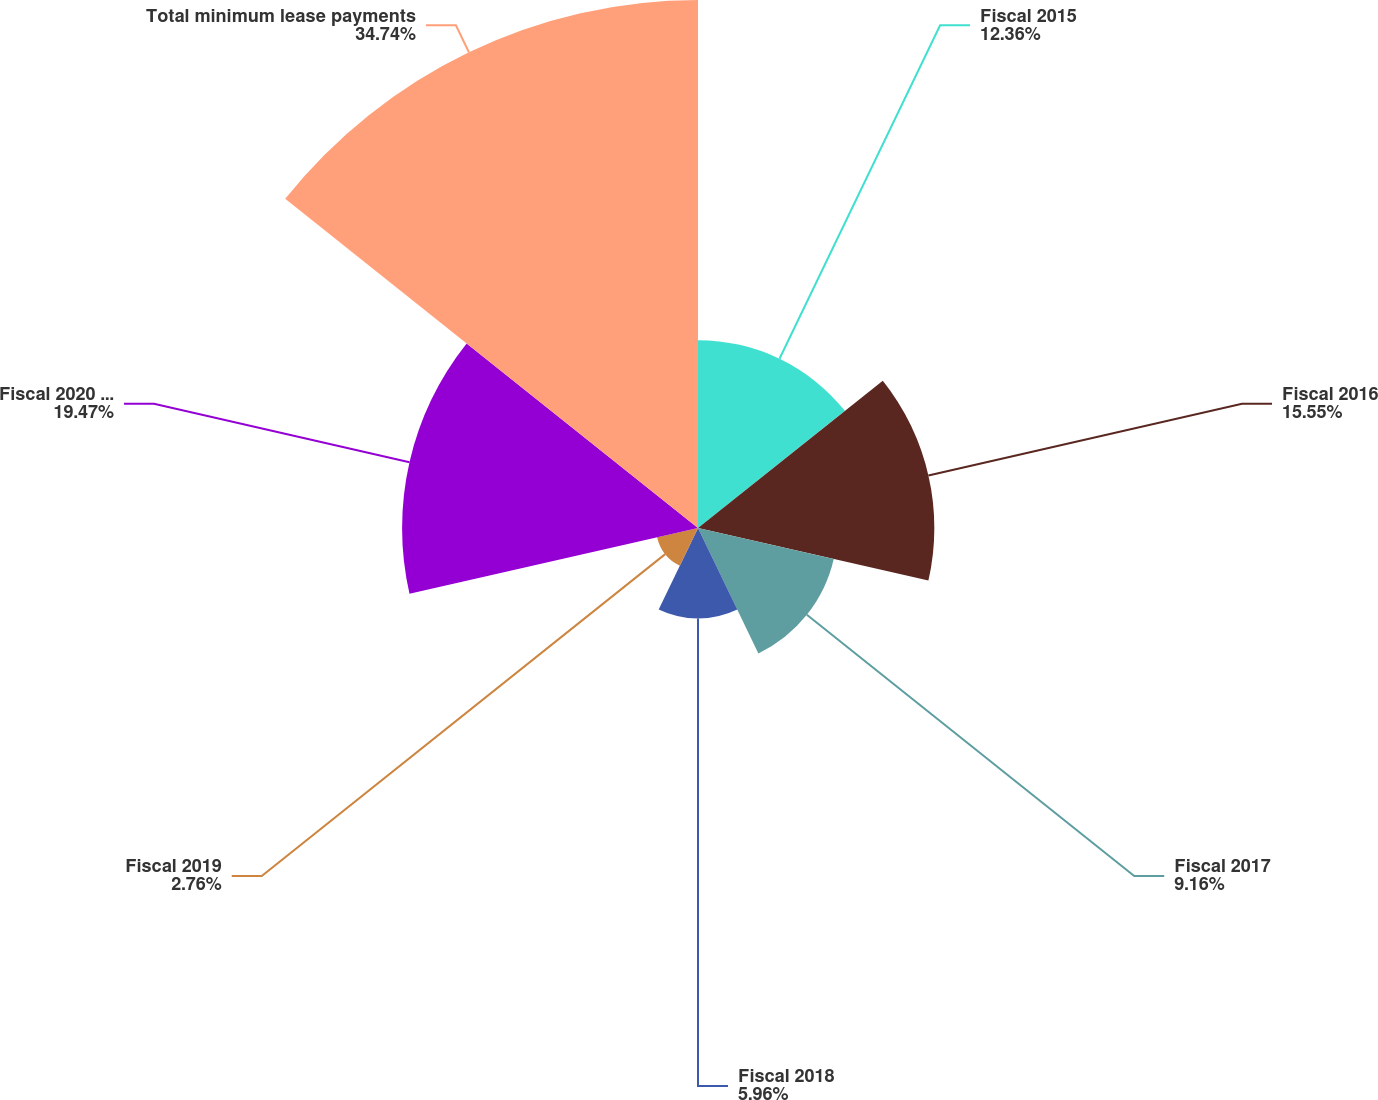<chart> <loc_0><loc_0><loc_500><loc_500><pie_chart><fcel>Fiscal 2015<fcel>Fiscal 2016<fcel>Fiscal 2017<fcel>Fiscal 2018<fcel>Fiscal 2019<fcel>Fiscal 2020 and thereafter<fcel>Total minimum lease payments<nl><fcel>12.36%<fcel>15.55%<fcel>9.16%<fcel>5.96%<fcel>2.76%<fcel>19.47%<fcel>34.74%<nl></chart> 